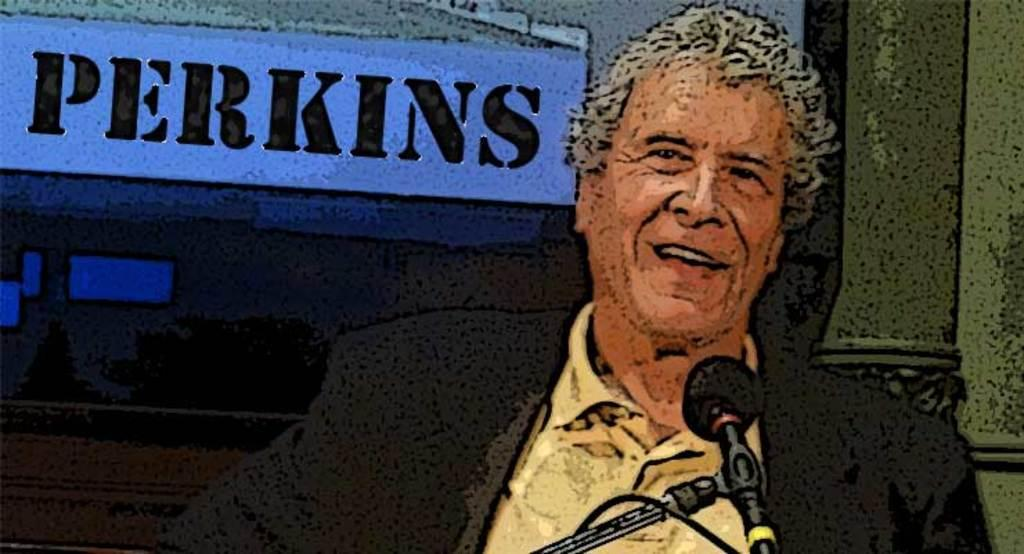Who is the main subject in the image? There is an old man in the image. What is the old man wearing? The old man is wearing a suit. What is the old man doing in the image? The old man is talking on a microphone. What can be seen in the background of the image? There is a wall in the background of the image. How is the image created? The image is a graphic illustration. How does the old man measure the fog in the image? There is no fog present in the image, and the old man is not measuring anything. 